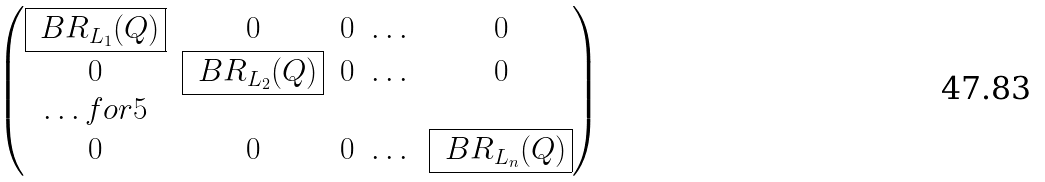Convert formula to latex. <formula><loc_0><loc_0><loc_500><loc_500>\begin{pmatrix} \boxed { \ B R _ { L _ { 1 } } ( Q ) } & 0 & 0 & \dots & 0 \\ 0 & \boxed { \ B R _ { L _ { 2 } } ( Q ) } & 0 & \dots & 0 \\ \hdots f o r { 5 } \\ 0 & 0 & 0 & \dots & \boxed { \ B R _ { L _ { n } } ( Q ) } \end{pmatrix}</formula> 